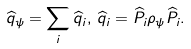<formula> <loc_0><loc_0><loc_500><loc_500>\widehat { q } _ { \psi } = \sum _ { i } \widehat { q } _ { i } , \, \widehat { q } _ { i } = \widehat { P } _ { i } \rho _ { \psi } \widehat { P } _ { i } .</formula> 